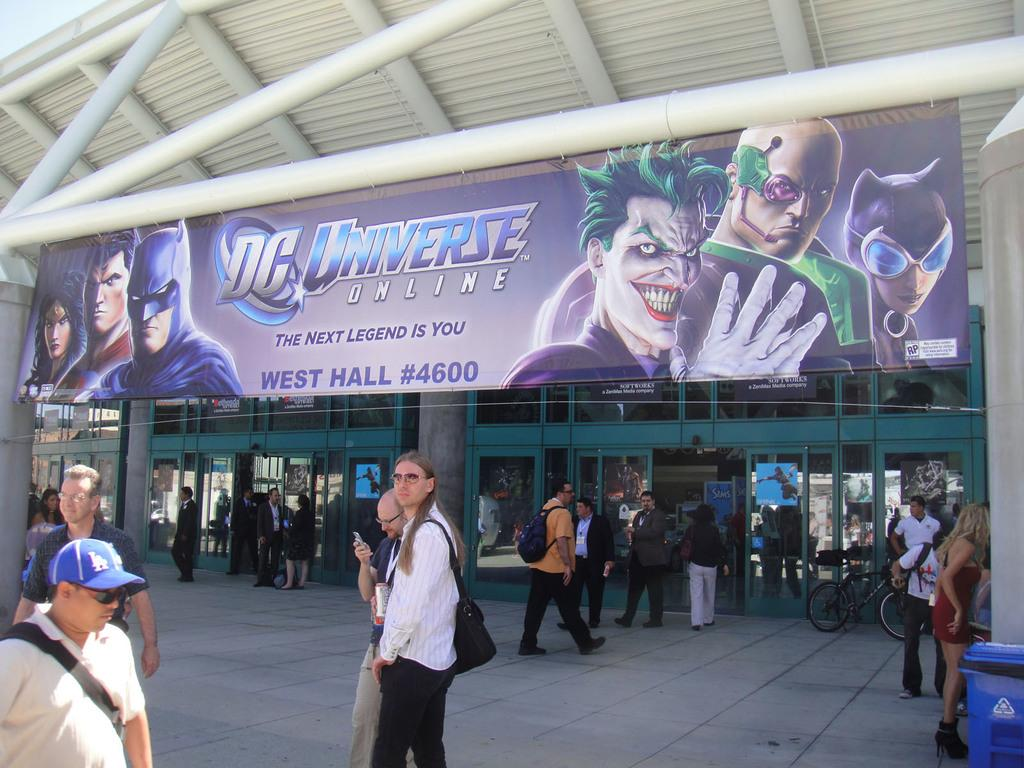<image>
Render a clear and concise summary of the photo. A group of people are milling around underneath of a large sign reading DC Universe Online. 